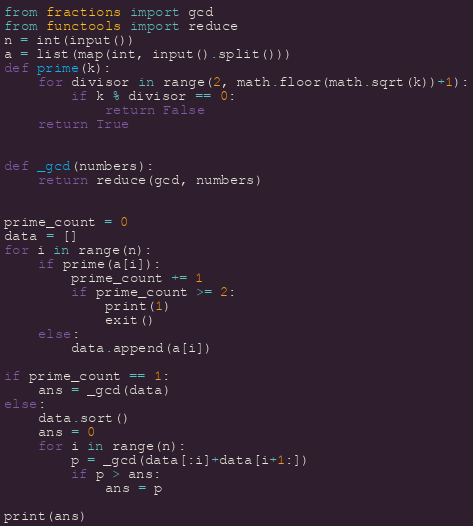<code> <loc_0><loc_0><loc_500><loc_500><_Python_>from fractions import gcd
from functools import reduce
n = int(input())
a = list(map(int, input().split()))
def prime(k):
    for divisor in range(2, math.floor(math.sqrt(k))+1):
        if k % divisor == 0:
            return False
    return True


def _gcd(numbers):
    return reduce(gcd, numbers)


prime_count = 0
data = []
for i in range(n):
    if prime(a[i]):
        prime_count += 1
        if prime_count >= 2:
            print(1)
            exit()
    else:
        data.append(a[i])

if prime_count == 1:
    ans = _gcd(data)
else:
    data.sort()
    ans = 0
    for i in range(n):
        p = _gcd(data[:i]+data[i+1:])
        if p > ans:
            ans = p

print(ans)
</code> 